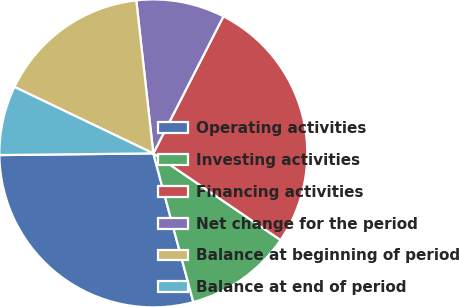<chart> <loc_0><loc_0><loc_500><loc_500><pie_chart><fcel>Operating activities<fcel>Investing activities<fcel>Financing activities<fcel>Net change for the period<fcel>Balance at beginning of period<fcel>Balance at end of period<nl><fcel>29.01%<fcel>11.3%<fcel>26.99%<fcel>9.29%<fcel>16.13%<fcel>7.28%<nl></chart> 